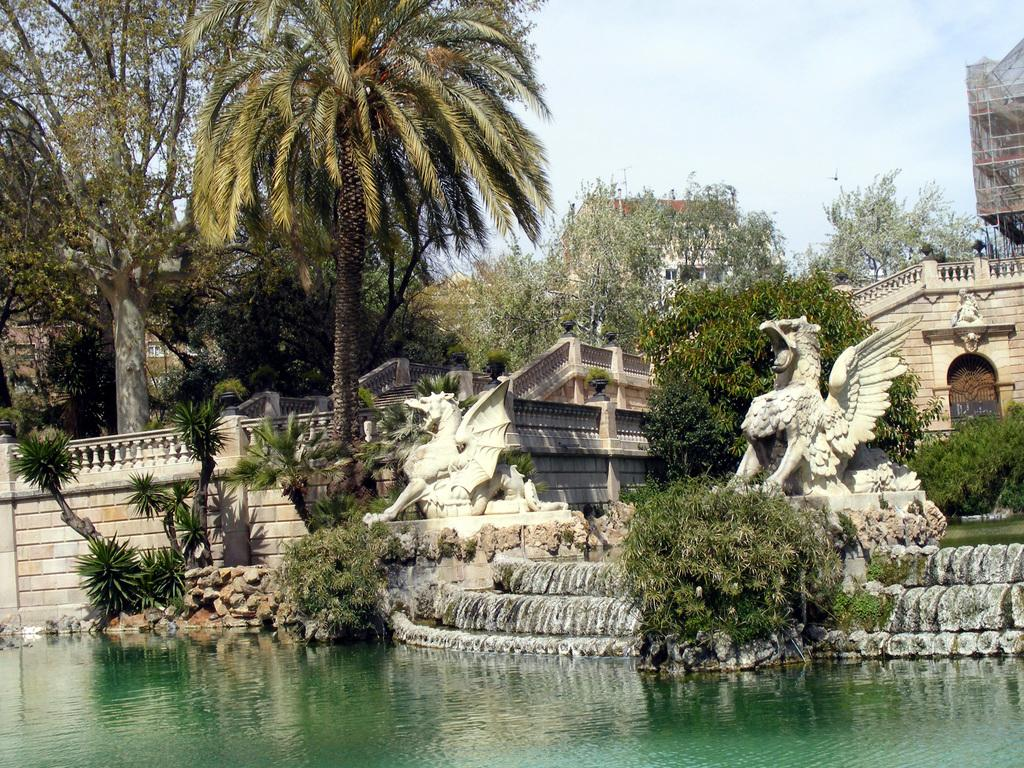What type of natural vegetation is visible in the image? There are trees in the image. What type of man-made structures can be seen in the image? There are buildings in the image. What architectural feature is present in the image? There are stairs in the image. What is visible in the image besides the structures and vegetation? There is water and the sky visible in the image. Can you see a kitty covering the water in the image? There is no kitty present in the image, and therefore no such activity can be observed. How many girls are visible in the image? There is no girl present in the image. 